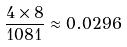<formula> <loc_0><loc_0><loc_500><loc_500>\frac { 4 \times 8 } { 1 0 8 1 } \approx 0 . 0 2 9 6</formula> 